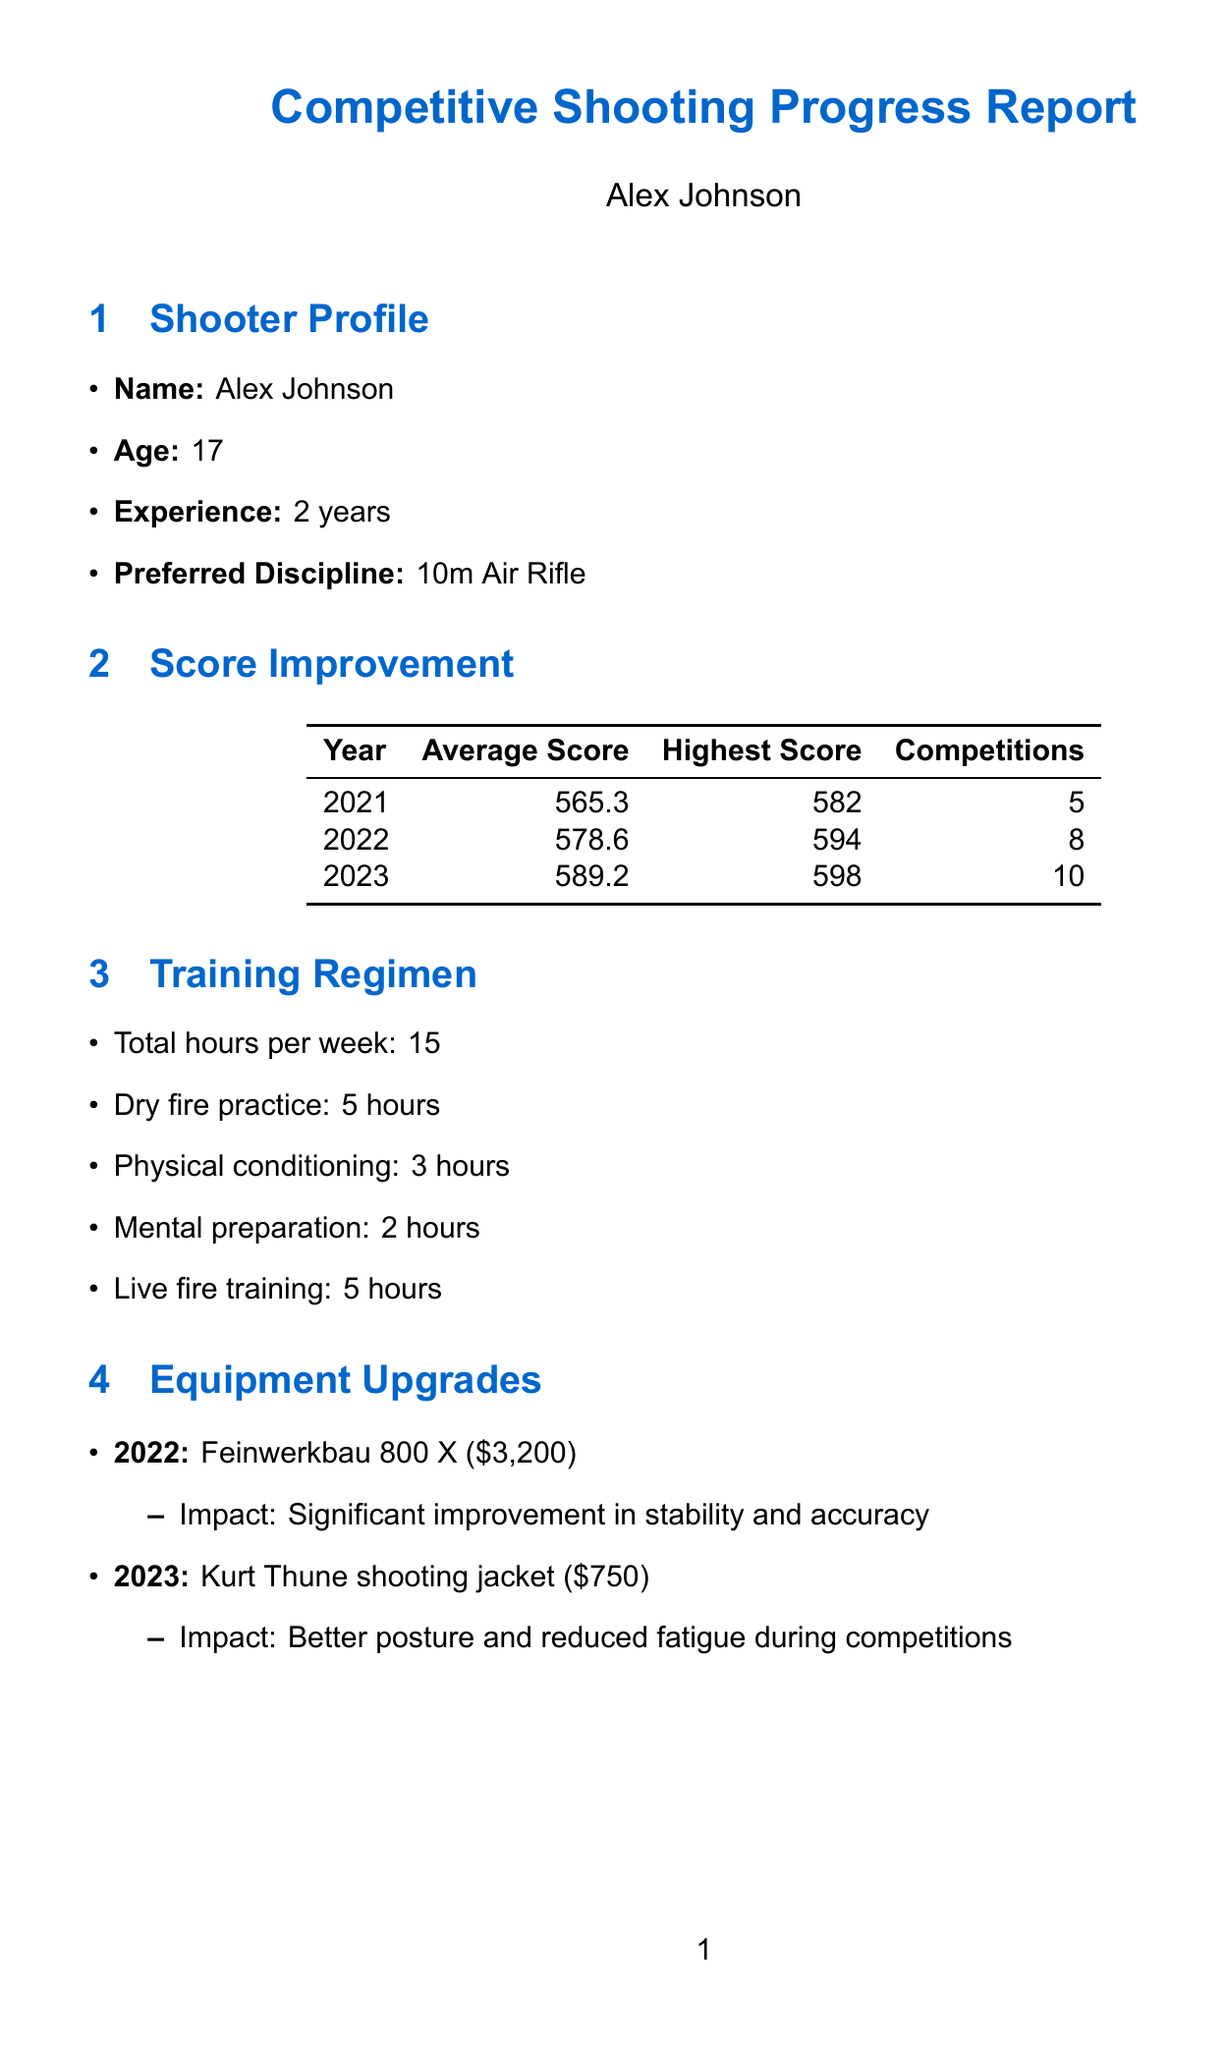What is Alex Johnson's age? The document states that Alex Johnson is 17 years old.
Answer: 17 What was Sarah Johnson's best achievement? According to the document, Sarah Johnson's best achievement was a silver medal in the 2012 National Championships.
Answer: Silver medal in 2012 National Championships What was Alex's highest score in 2023? The highest score listed for Alex in 2023 was 598.
Answer: 598 How many competitions did Alex attend in 2022? The document indicates that Alex attended 8 competitions in 2022.
Answer: 8 What is the total number of hours Alex trains each week? Alex trains a total of 15 hours per week as mentioned in the document.
Answer: 15 Which equipment did Alex upgrade in 2022? The document notes that Alex upgraded to the Feinwerkbau 800 X in 2022.
Answer: Feinwerkbau 800 X What placement did Alex achieve in the 2023 Junior Olympics? In the 2023 Junior Olympics, Alex placed 5th according to the document.
Answer: 5th What is one aspect of coach feedback given to Alex? The document states that the coach provided feedback on technique, mentioning excellent progress in shot execution.
Answer: Excellent progress in shot execution What is one of the future goals mentioned for Alex? One of the future goals for Alex is to qualify for the national team within the next two years.
Answer: Qualify for the national team within the next two years 